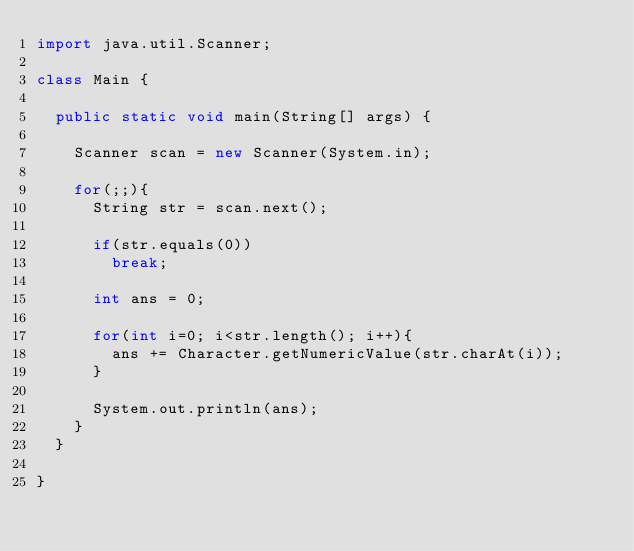Convert code to text. <code><loc_0><loc_0><loc_500><loc_500><_Java_>import java.util.Scanner;

class Main {

	public static void main(String[] args) {

		Scanner scan = new Scanner(System.in);

		for(;;){
			String str = scan.next();

			if(str.equals(0))
				break;

			int ans = 0;

			for(int i=0; i<str.length(); i++){
				ans += Character.getNumericValue(str.charAt(i));
			}

			System.out.println(ans);
		}
	}

}</code> 